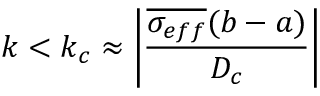Convert formula to latex. <formula><loc_0><loc_0><loc_500><loc_500>k < k _ { c } \approx \left | \frac { \overline { { \sigma _ { e f f } } } ( b - a ) } { D _ { c } } \right |</formula> 